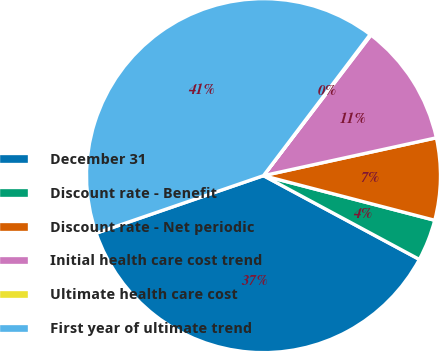Convert chart. <chart><loc_0><loc_0><loc_500><loc_500><pie_chart><fcel>December 31<fcel>Discount rate - Benefit<fcel>Discount rate - Net periodic<fcel>Initial health care cost trend<fcel>Ultimate health care cost<fcel>First year of ultimate trend<nl><fcel>36.88%<fcel>3.79%<fcel>7.49%<fcel>11.18%<fcel>0.09%<fcel>40.57%<nl></chart> 